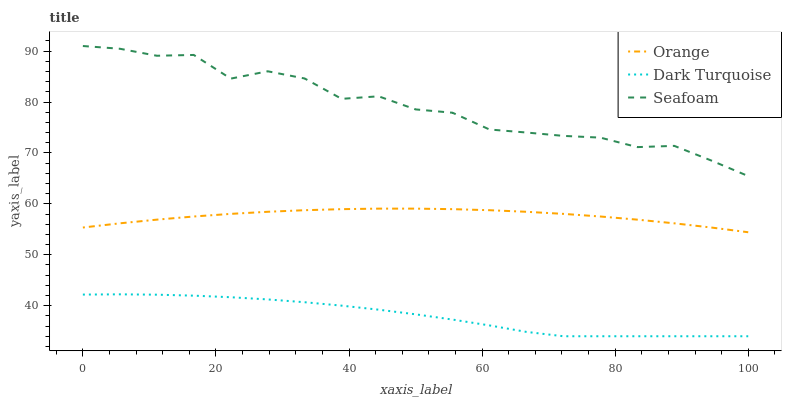Does Dark Turquoise have the minimum area under the curve?
Answer yes or no. Yes. Does Seafoam have the maximum area under the curve?
Answer yes or no. Yes. Does Seafoam have the minimum area under the curve?
Answer yes or no. No. Does Dark Turquoise have the maximum area under the curve?
Answer yes or no. No. Is Orange the smoothest?
Answer yes or no. Yes. Is Seafoam the roughest?
Answer yes or no. Yes. Is Dark Turquoise the smoothest?
Answer yes or no. No. Is Dark Turquoise the roughest?
Answer yes or no. No. Does Dark Turquoise have the lowest value?
Answer yes or no. Yes. Does Seafoam have the lowest value?
Answer yes or no. No. Does Seafoam have the highest value?
Answer yes or no. Yes. Does Dark Turquoise have the highest value?
Answer yes or no. No. Is Dark Turquoise less than Orange?
Answer yes or no. Yes. Is Seafoam greater than Dark Turquoise?
Answer yes or no. Yes. Does Dark Turquoise intersect Orange?
Answer yes or no. No. 